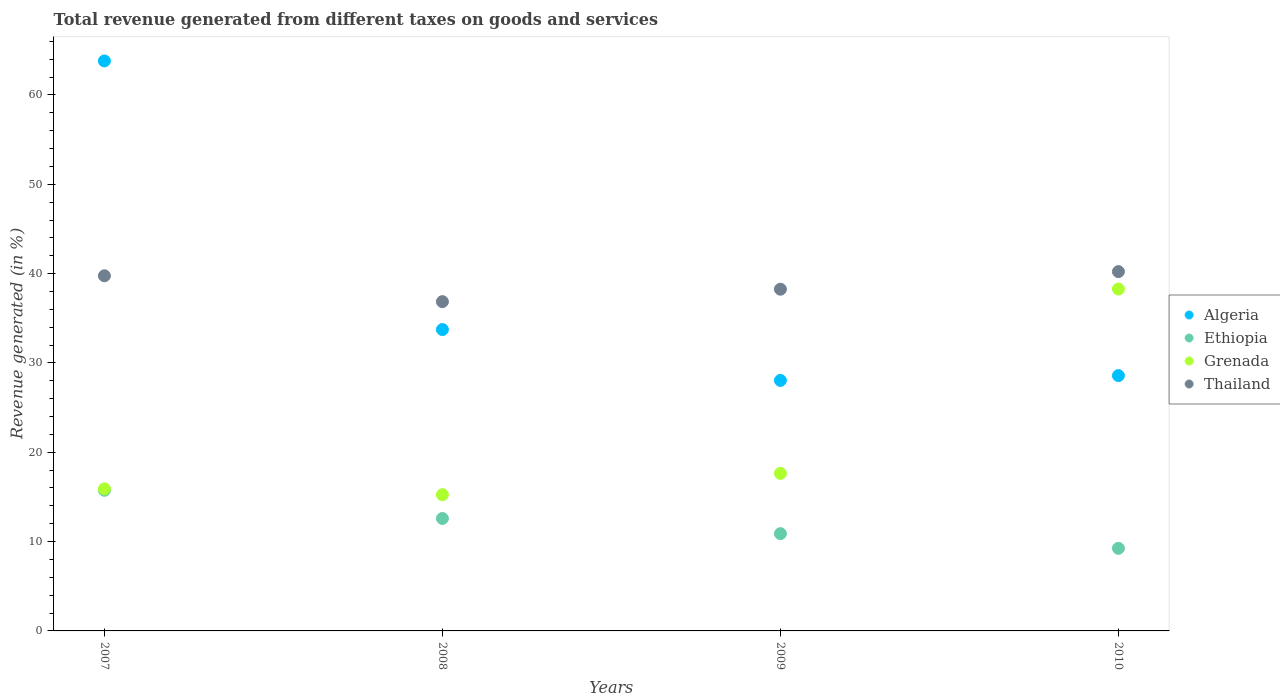What is the total revenue generated in Grenada in 2008?
Give a very brief answer. 15.25. Across all years, what is the maximum total revenue generated in Algeria?
Keep it short and to the point. 63.81. Across all years, what is the minimum total revenue generated in Ethiopia?
Provide a short and direct response. 9.25. In which year was the total revenue generated in Ethiopia maximum?
Your answer should be compact. 2007. What is the total total revenue generated in Grenada in the graph?
Ensure brevity in your answer.  87.06. What is the difference between the total revenue generated in Ethiopia in 2007 and that in 2010?
Make the answer very short. 6.5. What is the difference between the total revenue generated in Grenada in 2010 and the total revenue generated in Algeria in 2009?
Offer a terse response. 10.23. What is the average total revenue generated in Ethiopia per year?
Ensure brevity in your answer.  12.12. In the year 2007, what is the difference between the total revenue generated in Thailand and total revenue generated in Grenada?
Give a very brief answer. 23.85. What is the ratio of the total revenue generated in Grenada in 2008 to that in 2009?
Give a very brief answer. 0.86. Is the total revenue generated in Grenada in 2007 less than that in 2010?
Keep it short and to the point. Yes. Is the difference between the total revenue generated in Thailand in 2008 and 2010 greater than the difference between the total revenue generated in Grenada in 2008 and 2010?
Your answer should be very brief. Yes. What is the difference between the highest and the second highest total revenue generated in Algeria?
Your answer should be compact. 30.07. What is the difference between the highest and the lowest total revenue generated in Thailand?
Ensure brevity in your answer.  3.36. Is the sum of the total revenue generated in Thailand in 2008 and 2010 greater than the maximum total revenue generated in Grenada across all years?
Your answer should be compact. Yes. Is the total revenue generated in Thailand strictly greater than the total revenue generated in Grenada over the years?
Give a very brief answer. Yes. What is the difference between two consecutive major ticks on the Y-axis?
Your answer should be compact. 10. Are the values on the major ticks of Y-axis written in scientific E-notation?
Offer a terse response. No. Does the graph contain grids?
Your response must be concise. No. How many legend labels are there?
Provide a short and direct response. 4. How are the legend labels stacked?
Your response must be concise. Vertical. What is the title of the graph?
Offer a terse response. Total revenue generated from different taxes on goods and services. Does "Zimbabwe" appear as one of the legend labels in the graph?
Make the answer very short. No. What is the label or title of the Y-axis?
Offer a very short reply. Revenue generated (in %). What is the Revenue generated (in %) of Algeria in 2007?
Your response must be concise. 63.81. What is the Revenue generated (in %) in Ethiopia in 2007?
Give a very brief answer. 15.74. What is the Revenue generated (in %) of Grenada in 2007?
Your answer should be very brief. 15.9. What is the Revenue generated (in %) in Thailand in 2007?
Make the answer very short. 39.76. What is the Revenue generated (in %) of Algeria in 2008?
Provide a short and direct response. 33.74. What is the Revenue generated (in %) in Ethiopia in 2008?
Your answer should be very brief. 12.59. What is the Revenue generated (in %) in Grenada in 2008?
Offer a very short reply. 15.25. What is the Revenue generated (in %) in Thailand in 2008?
Keep it short and to the point. 36.86. What is the Revenue generated (in %) of Algeria in 2009?
Provide a short and direct response. 28.04. What is the Revenue generated (in %) of Ethiopia in 2009?
Make the answer very short. 10.89. What is the Revenue generated (in %) of Grenada in 2009?
Offer a terse response. 17.63. What is the Revenue generated (in %) in Thailand in 2009?
Make the answer very short. 38.25. What is the Revenue generated (in %) of Algeria in 2010?
Your answer should be very brief. 28.58. What is the Revenue generated (in %) in Ethiopia in 2010?
Your response must be concise. 9.25. What is the Revenue generated (in %) of Grenada in 2010?
Your answer should be very brief. 38.27. What is the Revenue generated (in %) in Thailand in 2010?
Provide a short and direct response. 40.22. Across all years, what is the maximum Revenue generated (in %) in Algeria?
Offer a terse response. 63.81. Across all years, what is the maximum Revenue generated (in %) in Ethiopia?
Your response must be concise. 15.74. Across all years, what is the maximum Revenue generated (in %) of Grenada?
Make the answer very short. 38.27. Across all years, what is the maximum Revenue generated (in %) in Thailand?
Your answer should be compact. 40.22. Across all years, what is the minimum Revenue generated (in %) of Algeria?
Your response must be concise. 28.04. Across all years, what is the minimum Revenue generated (in %) in Ethiopia?
Make the answer very short. 9.25. Across all years, what is the minimum Revenue generated (in %) in Grenada?
Make the answer very short. 15.25. Across all years, what is the minimum Revenue generated (in %) in Thailand?
Provide a short and direct response. 36.86. What is the total Revenue generated (in %) of Algeria in the graph?
Keep it short and to the point. 154.17. What is the total Revenue generated (in %) in Ethiopia in the graph?
Your response must be concise. 48.47. What is the total Revenue generated (in %) of Grenada in the graph?
Your answer should be compact. 87.06. What is the total Revenue generated (in %) in Thailand in the graph?
Offer a very short reply. 155.09. What is the difference between the Revenue generated (in %) in Algeria in 2007 and that in 2008?
Offer a very short reply. 30.07. What is the difference between the Revenue generated (in %) in Ethiopia in 2007 and that in 2008?
Give a very brief answer. 3.15. What is the difference between the Revenue generated (in %) in Grenada in 2007 and that in 2008?
Your response must be concise. 0.66. What is the difference between the Revenue generated (in %) in Thailand in 2007 and that in 2008?
Your answer should be very brief. 2.9. What is the difference between the Revenue generated (in %) in Algeria in 2007 and that in 2009?
Your response must be concise. 35.76. What is the difference between the Revenue generated (in %) of Ethiopia in 2007 and that in 2009?
Keep it short and to the point. 4.85. What is the difference between the Revenue generated (in %) in Grenada in 2007 and that in 2009?
Give a very brief answer. -1.73. What is the difference between the Revenue generated (in %) in Thailand in 2007 and that in 2009?
Make the answer very short. 1.5. What is the difference between the Revenue generated (in %) of Algeria in 2007 and that in 2010?
Provide a short and direct response. 35.22. What is the difference between the Revenue generated (in %) of Ethiopia in 2007 and that in 2010?
Keep it short and to the point. 6.5. What is the difference between the Revenue generated (in %) in Grenada in 2007 and that in 2010?
Give a very brief answer. -22.37. What is the difference between the Revenue generated (in %) in Thailand in 2007 and that in 2010?
Ensure brevity in your answer.  -0.47. What is the difference between the Revenue generated (in %) in Algeria in 2008 and that in 2009?
Offer a very short reply. 5.69. What is the difference between the Revenue generated (in %) in Ethiopia in 2008 and that in 2009?
Your answer should be very brief. 1.7. What is the difference between the Revenue generated (in %) of Grenada in 2008 and that in 2009?
Ensure brevity in your answer.  -2.38. What is the difference between the Revenue generated (in %) in Thailand in 2008 and that in 2009?
Keep it short and to the point. -1.39. What is the difference between the Revenue generated (in %) of Algeria in 2008 and that in 2010?
Make the answer very short. 5.15. What is the difference between the Revenue generated (in %) in Ethiopia in 2008 and that in 2010?
Offer a terse response. 3.34. What is the difference between the Revenue generated (in %) of Grenada in 2008 and that in 2010?
Give a very brief answer. -23.02. What is the difference between the Revenue generated (in %) in Thailand in 2008 and that in 2010?
Your response must be concise. -3.36. What is the difference between the Revenue generated (in %) in Algeria in 2009 and that in 2010?
Your answer should be compact. -0.54. What is the difference between the Revenue generated (in %) of Ethiopia in 2009 and that in 2010?
Keep it short and to the point. 1.64. What is the difference between the Revenue generated (in %) of Grenada in 2009 and that in 2010?
Offer a very short reply. -20.64. What is the difference between the Revenue generated (in %) of Thailand in 2009 and that in 2010?
Your response must be concise. -1.97. What is the difference between the Revenue generated (in %) in Algeria in 2007 and the Revenue generated (in %) in Ethiopia in 2008?
Provide a short and direct response. 51.22. What is the difference between the Revenue generated (in %) in Algeria in 2007 and the Revenue generated (in %) in Grenada in 2008?
Your answer should be compact. 48.56. What is the difference between the Revenue generated (in %) in Algeria in 2007 and the Revenue generated (in %) in Thailand in 2008?
Provide a short and direct response. 26.95. What is the difference between the Revenue generated (in %) of Ethiopia in 2007 and the Revenue generated (in %) of Grenada in 2008?
Provide a succinct answer. 0.49. What is the difference between the Revenue generated (in %) of Ethiopia in 2007 and the Revenue generated (in %) of Thailand in 2008?
Make the answer very short. -21.12. What is the difference between the Revenue generated (in %) of Grenada in 2007 and the Revenue generated (in %) of Thailand in 2008?
Provide a short and direct response. -20.96. What is the difference between the Revenue generated (in %) of Algeria in 2007 and the Revenue generated (in %) of Ethiopia in 2009?
Ensure brevity in your answer.  52.92. What is the difference between the Revenue generated (in %) of Algeria in 2007 and the Revenue generated (in %) of Grenada in 2009?
Ensure brevity in your answer.  46.17. What is the difference between the Revenue generated (in %) of Algeria in 2007 and the Revenue generated (in %) of Thailand in 2009?
Offer a terse response. 25.55. What is the difference between the Revenue generated (in %) in Ethiopia in 2007 and the Revenue generated (in %) in Grenada in 2009?
Make the answer very short. -1.89. What is the difference between the Revenue generated (in %) in Ethiopia in 2007 and the Revenue generated (in %) in Thailand in 2009?
Your answer should be compact. -22.51. What is the difference between the Revenue generated (in %) in Grenada in 2007 and the Revenue generated (in %) in Thailand in 2009?
Your answer should be compact. -22.35. What is the difference between the Revenue generated (in %) in Algeria in 2007 and the Revenue generated (in %) in Ethiopia in 2010?
Give a very brief answer. 54.56. What is the difference between the Revenue generated (in %) of Algeria in 2007 and the Revenue generated (in %) of Grenada in 2010?
Provide a succinct answer. 25.53. What is the difference between the Revenue generated (in %) in Algeria in 2007 and the Revenue generated (in %) in Thailand in 2010?
Ensure brevity in your answer.  23.58. What is the difference between the Revenue generated (in %) in Ethiopia in 2007 and the Revenue generated (in %) in Grenada in 2010?
Provide a succinct answer. -22.53. What is the difference between the Revenue generated (in %) in Ethiopia in 2007 and the Revenue generated (in %) in Thailand in 2010?
Provide a succinct answer. -24.48. What is the difference between the Revenue generated (in %) in Grenada in 2007 and the Revenue generated (in %) in Thailand in 2010?
Provide a short and direct response. -24.32. What is the difference between the Revenue generated (in %) in Algeria in 2008 and the Revenue generated (in %) in Ethiopia in 2009?
Provide a succinct answer. 22.85. What is the difference between the Revenue generated (in %) of Algeria in 2008 and the Revenue generated (in %) of Grenada in 2009?
Make the answer very short. 16.1. What is the difference between the Revenue generated (in %) in Algeria in 2008 and the Revenue generated (in %) in Thailand in 2009?
Your response must be concise. -4.52. What is the difference between the Revenue generated (in %) in Ethiopia in 2008 and the Revenue generated (in %) in Grenada in 2009?
Provide a short and direct response. -5.04. What is the difference between the Revenue generated (in %) of Ethiopia in 2008 and the Revenue generated (in %) of Thailand in 2009?
Offer a terse response. -25.66. What is the difference between the Revenue generated (in %) in Grenada in 2008 and the Revenue generated (in %) in Thailand in 2009?
Your response must be concise. -23. What is the difference between the Revenue generated (in %) in Algeria in 2008 and the Revenue generated (in %) in Ethiopia in 2010?
Ensure brevity in your answer.  24.49. What is the difference between the Revenue generated (in %) in Algeria in 2008 and the Revenue generated (in %) in Grenada in 2010?
Make the answer very short. -4.54. What is the difference between the Revenue generated (in %) of Algeria in 2008 and the Revenue generated (in %) of Thailand in 2010?
Make the answer very short. -6.49. What is the difference between the Revenue generated (in %) of Ethiopia in 2008 and the Revenue generated (in %) of Grenada in 2010?
Your response must be concise. -25.68. What is the difference between the Revenue generated (in %) in Ethiopia in 2008 and the Revenue generated (in %) in Thailand in 2010?
Offer a terse response. -27.63. What is the difference between the Revenue generated (in %) in Grenada in 2008 and the Revenue generated (in %) in Thailand in 2010?
Ensure brevity in your answer.  -24.97. What is the difference between the Revenue generated (in %) in Algeria in 2009 and the Revenue generated (in %) in Ethiopia in 2010?
Offer a terse response. 18.8. What is the difference between the Revenue generated (in %) in Algeria in 2009 and the Revenue generated (in %) in Grenada in 2010?
Provide a succinct answer. -10.23. What is the difference between the Revenue generated (in %) in Algeria in 2009 and the Revenue generated (in %) in Thailand in 2010?
Offer a terse response. -12.18. What is the difference between the Revenue generated (in %) in Ethiopia in 2009 and the Revenue generated (in %) in Grenada in 2010?
Make the answer very short. -27.38. What is the difference between the Revenue generated (in %) of Ethiopia in 2009 and the Revenue generated (in %) of Thailand in 2010?
Provide a succinct answer. -29.33. What is the difference between the Revenue generated (in %) of Grenada in 2009 and the Revenue generated (in %) of Thailand in 2010?
Offer a terse response. -22.59. What is the average Revenue generated (in %) in Algeria per year?
Your answer should be very brief. 38.54. What is the average Revenue generated (in %) in Ethiopia per year?
Ensure brevity in your answer.  12.12. What is the average Revenue generated (in %) of Grenada per year?
Give a very brief answer. 21.77. What is the average Revenue generated (in %) in Thailand per year?
Provide a short and direct response. 38.77. In the year 2007, what is the difference between the Revenue generated (in %) in Algeria and Revenue generated (in %) in Ethiopia?
Your answer should be compact. 48.06. In the year 2007, what is the difference between the Revenue generated (in %) in Algeria and Revenue generated (in %) in Grenada?
Offer a very short reply. 47.9. In the year 2007, what is the difference between the Revenue generated (in %) of Algeria and Revenue generated (in %) of Thailand?
Make the answer very short. 24.05. In the year 2007, what is the difference between the Revenue generated (in %) in Ethiopia and Revenue generated (in %) in Grenada?
Provide a short and direct response. -0.16. In the year 2007, what is the difference between the Revenue generated (in %) of Ethiopia and Revenue generated (in %) of Thailand?
Your answer should be compact. -24.01. In the year 2007, what is the difference between the Revenue generated (in %) of Grenada and Revenue generated (in %) of Thailand?
Your response must be concise. -23.85. In the year 2008, what is the difference between the Revenue generated (in %) of Algeria and Revenue generated (in %) of Ethiopia?
Give a very brief answer. 21.15. In the year 2008, what is the difference between the Revenue generated (in %) of Algeria and Revenue generated (in %) of Grenada?
Your answer should be compact. 18.49. In the year 2008, what is the difference between the Revenue generated (in %) of Algeria and Revenue generated (in %) of Thailand?
Offer a very short reply. -3.12. In the year 2008, what is the difference between the Revenue generated (in %) in Ethiopia and Revenue generated (in %) in Grenada?
Offer a terse response. -2.66. In the year 2008, what is the difference between the Revenue generated (in %) of Ethiopia and Revenue generated (in %) of Thailand?
Give a very brief answer. -24.27. In the year 2008, what is the difference between the Revenue generated (in %) of Grenada and Revenue generated (in %) of Thailand?
Keep it short and to the point. -21.61. In the year 2009, what is the difference between the Revenue generated (in %) of Algeria and Revenue generated (in %) of Ethiopia?
Provide a succinct answer. 17.15. In the year 2009, what is the difference between the Revenue generated (in %) in Algeria and Revenue generated (in %) in Grenada?
Provide a short and direct response. 10.41. In the year 2009, what is the difference between the Revenue generated (in %) in Algeria and Revenue generated (in %) in Thailand?
Keep it short and to the point. -10.21. In the year 2009, what is the difference between the Revenue generated (in %) of Ethiopia and Revenue generated (in %) of Grenada?
Give a very brief answer. -6.74. In the year 2009, what is the difference between the Revenue generated (in %) in Ethiopia and Revenue generated (in %) in Thailand?
Your response must be concise. -27.36. In the year 2009, what is the difference between the Revenue generated (in %) of Grenada and Revenue generated (in %) of Thailand?
Provide a succinct answer. -20.62. In the year 2010, what is the difference between the Revenue generated (in %) in Algeria and Revenue generated (in %) in Ethiopia?
Keep it short and to the point. 19.34. In the year 2010, what is the difference between the Revenue generated (in %) of Algeria and Revenue generated (in %) of Grenada?
Provide a short and direct response. -9.69. In the year 2010, what is the difference between the Revenue generated (in %) in Algeria and Revenue generated (in %) in Thailand?
Make the answer very short. -11.64. In the year 2010, what is the difference between the Revenue generated (in %) in Ethiopia and Revenue generated (in %) in Grenada?
Your answer should be compact. -29.03. In the year 2010, what is the difference between the Revenue generated (in %) in Ethiopia and Revenue generated (in %) in Thailand?
Make the answer very short. -30.98. In the year 2010, what is the difference between the Revenue generated (in %) in Grenada and Revenue generated (in %) in Thailand?
Offer a very short reply. -1.95. What is the ratio of the Revenue generated (in %) of Algeria in 2007 to that in 2008?
Give a very brief answer. 1.89. What is the ratio of the Revenue generated (in %) of Ethiopia in 2007 to that in 2008?
Offer a terse response. 1.25. What is the ratio of the Revenue generated (in %) in Grenada in 2007 to that in 2008?
Ensure brevity in your answer.  1.04. What is the ratio of the Revenue generated (in %) of Thailand in 2007 to that in 2008?
Offer a terse response. 1.08. What is the ratio of the Revenue generated (in %) in Algeria in 2007 to that in 2009?
Offer a very short reply. 2.28. What is the ratio of the Revenue generated (in %) of Ethiopia in 2007 to that in 2009?
Offer a terse response. 1.45. What is the ratio of the Revenue generated (in %) of Grenada in 2007 to that in 2009?
Give a very brief answer. 0.9. What is the ratio of the Revenue generated (in %) in Thailand in 2007 to that in 2009?
Offer a terse response. 1.04. What is the ratio of the Revenue generated (in %) in Algeria in 2007 to that in 2010?
Offer a very short reply. 2.23. What is the ratio of the Revenue generated (in %) in Ethiopia in 2007 to that in 2010?
Give a very brief answer. 1.7. What is the ratio of the Revenue generated (in %) of Grenada in 2007 to that in 2010?
Give a very brief answer. 0.42. What is the ratio of the Revenue generated (in %) in Thailand in 2007 to that in 2010?
Your answer should be compact. 0.99. What is the ratio of the Revenue generated (in %) of Algeria in 2008 to that in 2009?
Your response must be concise. 1.2. What is the ratio of the Revenue generated (in %) in Ethiopia in 2008 to that in 2009?
Make the answer very short. 1.16. What is the ratio of the Revenue generated (in %) in Grenada in 2008 to that in 2009?
Ensure brevity in your answer.  0.86. What is the ratio of the Revenue generated (in %) in Thailand in 2008 to that in 2009?
Make the answer very short. 0.96. What is the ratio of the Revenue generated (in %) in Algeria in 2008 to that in 2010?
Offer a terse response. 1.18. What is the ratio of the Revenue generated (in %) in Ethiopia in 2008 to that in 2010?
Offer a terse response. 1.36. What is the ratio of the Revenue generated (in %) of Grenada in 2008 to that in 2010?
Offer a very short reply. 0.4. What is the ratio of the Revenue generated (in %) of Thailand in 2008 to that in 2010?
Give a very brief answer. 0.92. What is the ratio of the Revenue generated (in %) in Algeria in 2009 to that in 2010?
Provide a short and direct response. 0.98. What is the ratio of the Revenue generated (in %) in Ethiopia in 2009 to that in 2010?
Provide a succinct answer. 1.18. What is the ratio of the Revenue generated (in %) of Grenada in 2009 to that in 2010?
Provide a succinct answer. 0.46. What is the ratio of the Revenue generated (in %) in Thailand in 2009 to that in 2010?
Offer a very short reply. 0.95. What is the difference between the highest and the second highest Revenue generated (in %) in Algeria?
Your answer should be compact. 30.07. What is the difference between the highest and the second highest Revenue generated (in %) in Ethiopia?
Make the answer very short. 3.15. What is the difference between the highest and the second highest Revenue generated (in %) in Grenada?
Make the answer very short. 20.64. What is the difference between the highest and the second highest Revenue generated (in %) in Thailand?
Your answer should be very brief. 0.47. What is the difference between the highest and the lowest Revenue generated (in %) in Algeria?
Offer a terse response. 35.76. What is the difference between the highest and the lowest Revenue generated (in %) of Ethiopia?
Keep it short and to the point. 6.5. What is the difference between the highest and the lowest Revenue generated (in %) of Grenada?
Provide a succinct answer. 23.02. What is the difference between the highest and the lowest Revenue generated (in %) of Thailand?
Your answer should be compact. 3.36. 